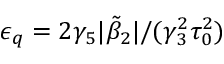Convert formula to latex. <formula><loc_0><loc_0><loc_500><loc_500>\epsilon _ { q } = 2 \gamma _ { 5 } | \tilde { \beta } _ { 2 } | / ( \gamma _ { 3 } ^ { 2 } \tau _ { 0 } ^ { 2 } )</formula> 